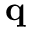Convert formula to latex. <formula><loc_0><loc_0><loc_500><loc_500>q</formula> 